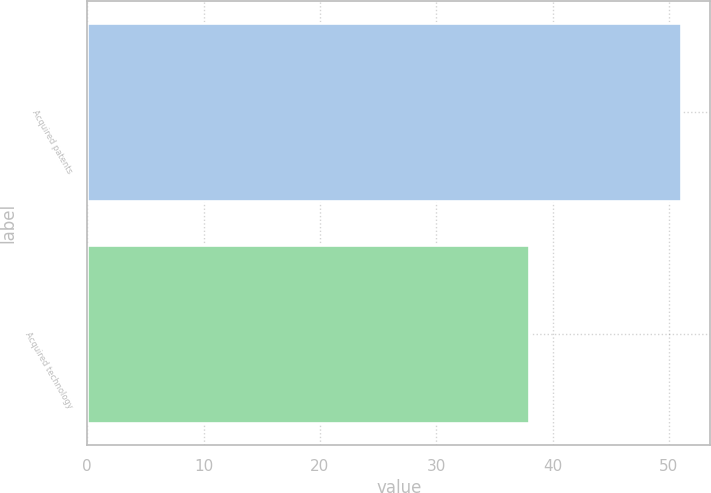Convert chart. <chart><loc_0><loc_0><loc_500><loc_500><bar_chart><fcel>Acquired patents<fcel>Acquired technology<nl><fcel>51<fcel>38<nl></chart> 